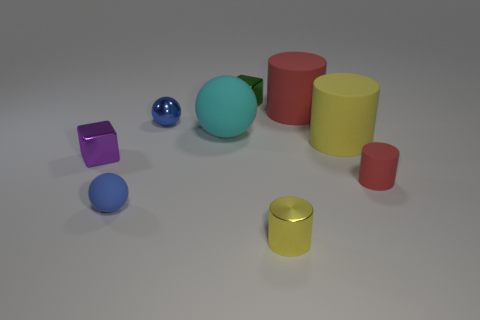Add 1 small blue rubber cubes. How many objects exist? 10 Subtract all cubes. How many objects are left? 7 Subtract 0 purple balls. How many objects are left? 9 Subtract all red cylinders. Subtract all small yellow metal cylinders. How many objects are left? 6 Add 3 purple blocks. How many purple blocks are left? 4 Add 3 cyan rubber things. How many cyan rubber things exist? 4 